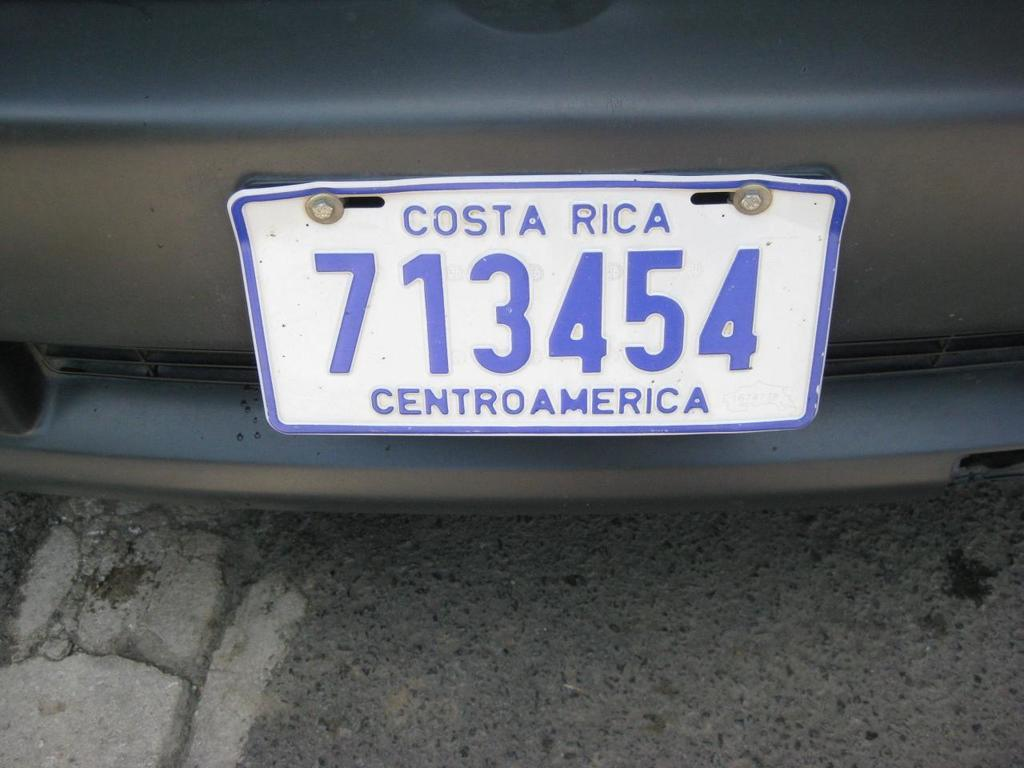<image>
Render a clear and concise summary of the photo. a costa rica license plate that is on a car 